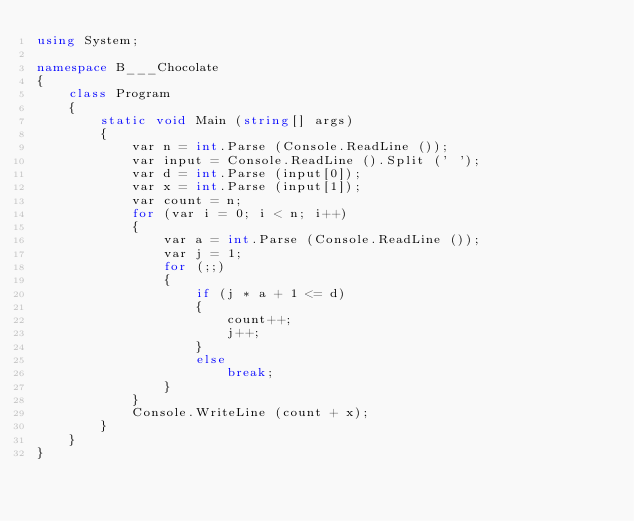<code> <loc_0><loc_0><loc_500><loc_500><_C#_>using System;

namespace B___Chocolate
{
    class Program
    {
        static void Main (string[] args)
        {
            var n = int.Parse (Console.ReadLine ());
            var input = Console.ReadLine ().Split (' ');
            var d = int.Parse (input[0]);
            var x = int.Parse (input[1]);
            var count = n;
            for (var i = 0; i < n; i++)
            {
                var a = int.Parse (Console.ReadLine ());
                var j = 1;
                for (;;)
                {
                    if (j * a + 1 <= d)
                    {
                        count++;
                        j++;
                    }
                    else
                        break;
                }
            }
            Console.WriteLine (count + x);
        }
    }
}</code> 